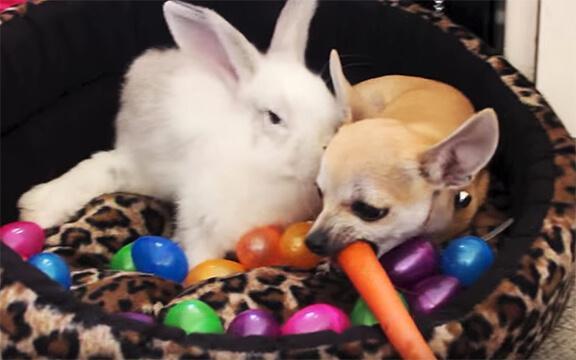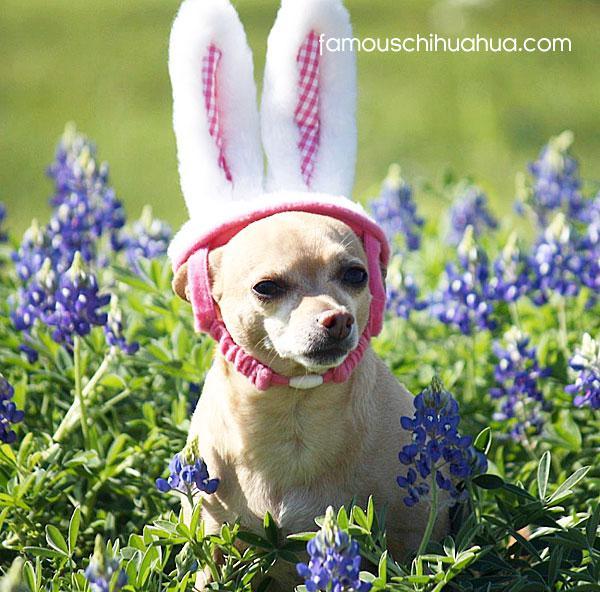The first image is the image on the left, the second image is the image on the right. For the images shown, is this caption "A dog has an orange carrot in an image that includes bunny ears." true? Answer yes or no. Yes. The first image is the image on the left, the second image is the image on the right. For the images shown, is this caption "The left image has a carrot." true? Answer yes or no. Yes. 